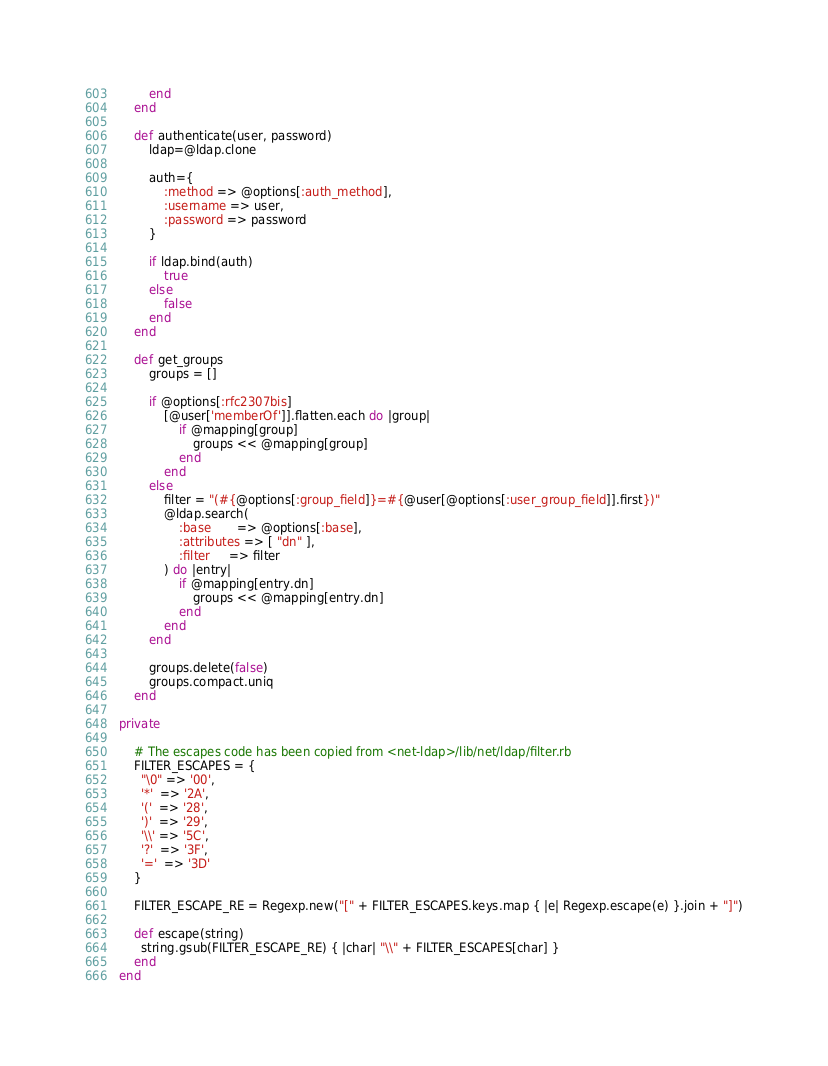Convert code to text. <code><loc_0><loc_0><loc_500><loc_500><_Ruby_>        end
    end

    def authenticate(user, password)
        ldap=@ldap.clone

        auth={
            :method => @options[:auth_method],
            :username => user,
            :password => password
        }

        if ldap.bind(auth)
            true
        else
            false
        end
    end

    def get_groups
        groups = []

        if @options[:rfc2307bis]
            [@user['memberOf']].flatten.each do |group|
                if @mapping[group]
                    groups << @mapping[group]
                end
            end
        else
            filter = "(#{@options[:group_field]}=#{@user[@options[:user_group_field]].first})"
            @ldap.search(
                :base       => @options[:base],
                :attributes => [ "dn" ],
                :filter     => filter
            ) do |entry|
                if @mapping[entry.dn]
                    groups << @mapping[entry.dn]
                end
            end
        end

        groups.delete(false)
        groups.compact.uniq
    end

private

    # The escapes code has been copied from <net-ldap>/lib/net/ldap/filter.rb
    FILTER_ESCAPES = {
      "\0" => '00',
      '*'  => '2A',
      '('  => '28',
      ')'  => '29',
      '\\' => '5C',
      '?'  => '3F',
      '='  => '3D'
    }

    FILTER_ESCAPE_RE = Regexp.new("[" + FILTER_ESCAPES.keys.map { |e| Regexp.escape(e) }.join + "]")

    def escape(string)
      string.gsub(FILTER_ESCAPE_RE) { |char| "\\" + FILTER_ESCAPES[char] }
    end
end
</code> 